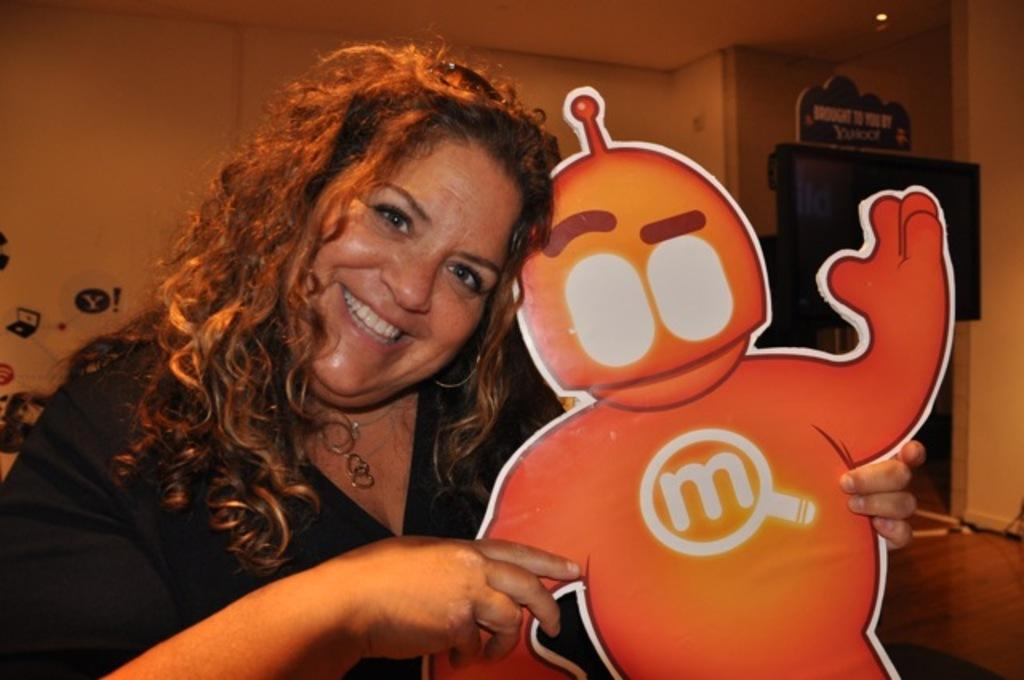<image>
Give a short and clear explanation of the subsequent image. woman holding cutout of a character that has a magnifying glass and an m on his chest 